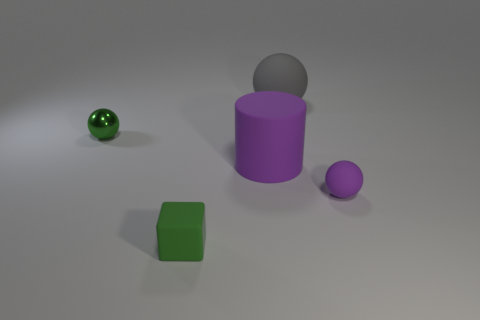Add 1 balls. How many objects exist? 6 Subtract all cylinders. How many objects are left? 4 Add 1 big gray shiny things. How many big gray shiny things exist? 1 Subtract 1 green spheres. How many objects are left? 4 Subtract all large gray rubber things. Subtract all tiny spheres. How many objects are left? 2 Add 2 small spheres. How many small spheres are left? 4 